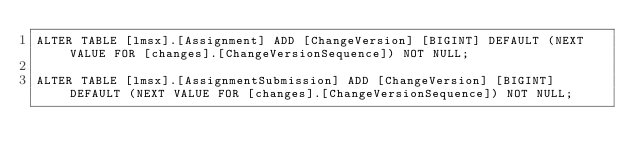<code> <loc_0><loc_0><loc_500><loc_500><_SQL_>ALTER TABLE [lmsx].[Assignment] ADD [ChangeVersion] [BIGINT] DEFAULT (NEXT VALUE FOR [changes].[ChangeVersionSequence]) NOT NULL;

ALTER TABLE [lmsx].[AssignmentSubmission] ADD [ChangeVersion] [BIGINT] DEFAULT (NEXT VALUE FOR [changes].[ChangeVersionSequence]) NOT NULL;

</code> 